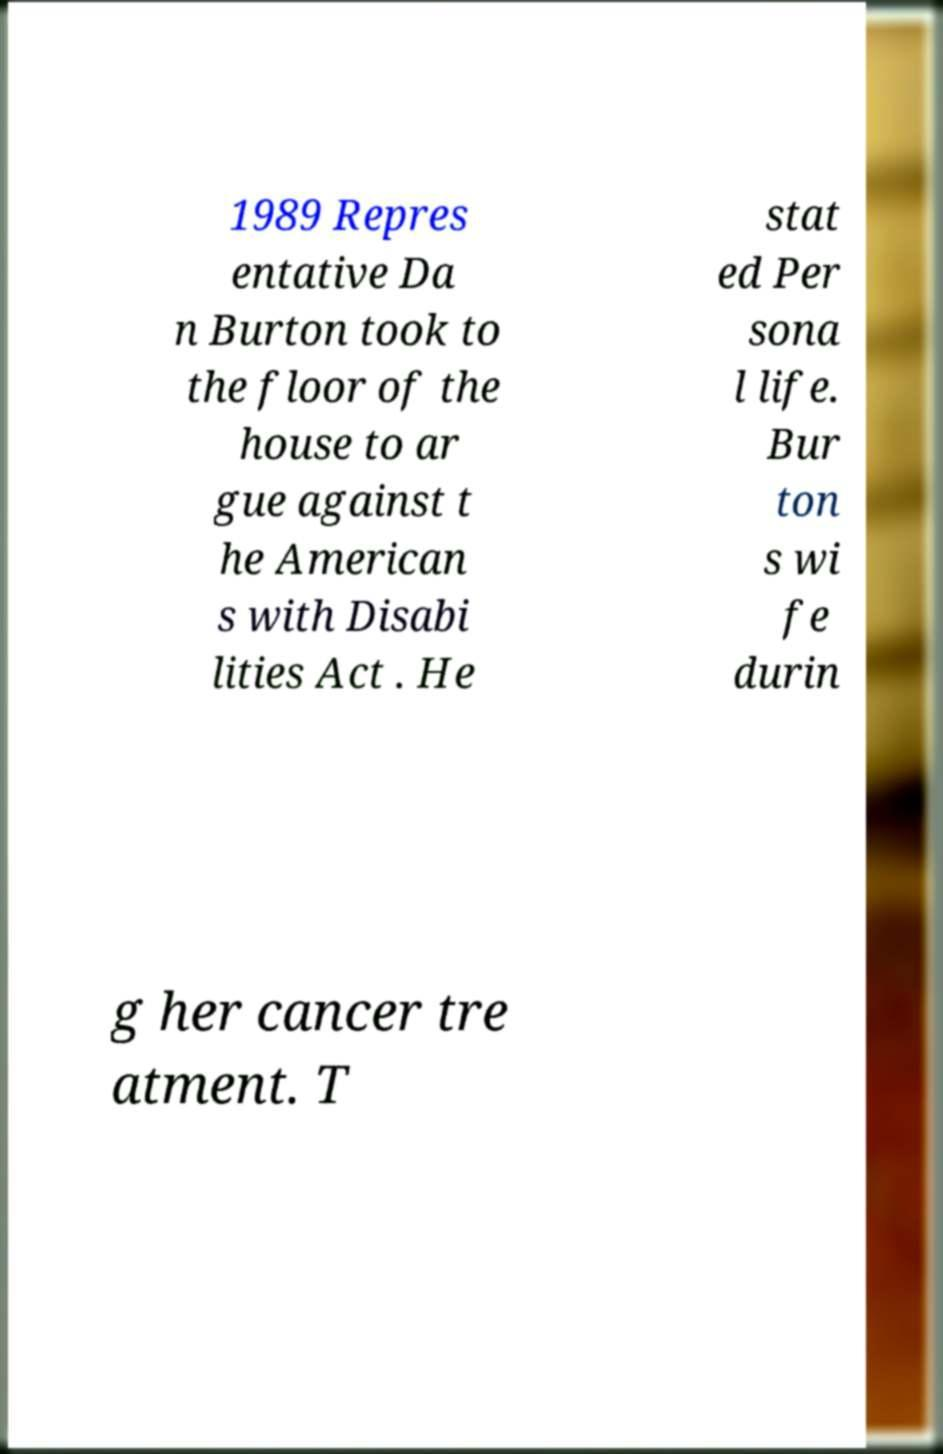Could you assist in decoding the text presented in this image and type it out clearly? 1989 Repres entative Da n Burton took to the floor of the house to ar gue against t he American s with Disabi lities Act . He stat ed Per sona l life. Bur ton s wi fe durin g her cancer tre atment. T 